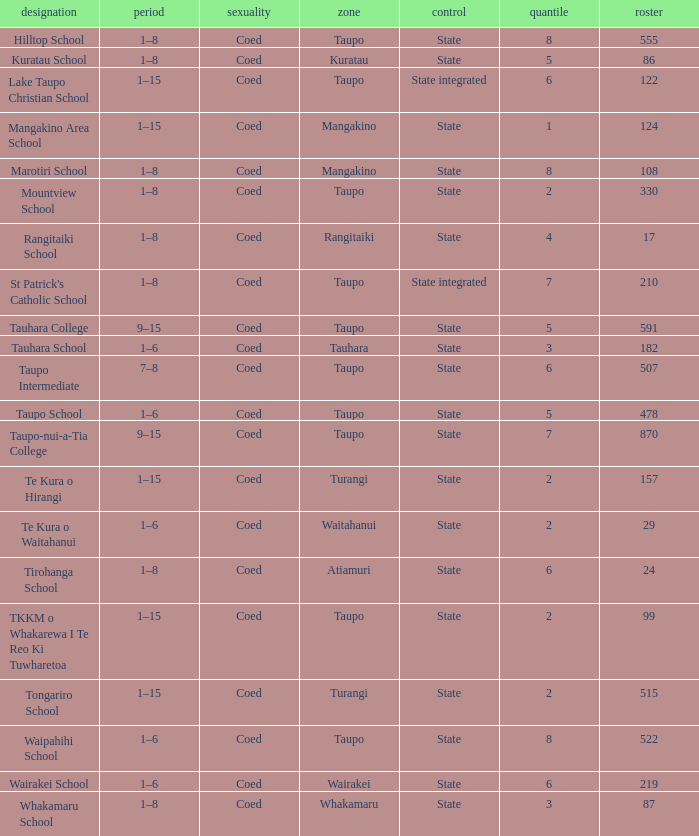Where is the school with state authority that has a roll of more than 157 students? Taupo, Taupo, Taupo, Tauhara, Taupo, Taupo, Taupo, Turangi, Taupo, Wairakei. 